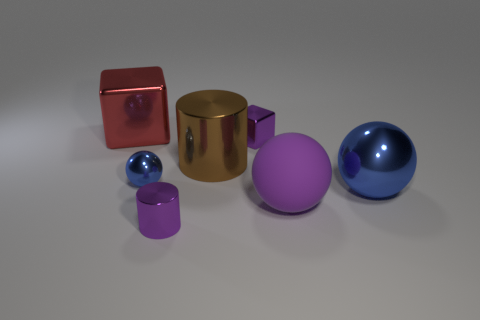What size is the matte object that is the same color as the tiny cylinder?
Keep it short and to the point. Large. How many things are to the left of the tiny cylinder and behind the brown shiny cylinder?
Your answer should be very brief. 1. How many things are big spheres or large objects that are to the left of the matte thing?
Your response must be concise. 4. The purple cube that is the same material as the large red cube is what size?
Your response must be concise. Small. What shape is the blue thing behind the ball that is right of the rubber object?
Give a very brief answer. Sphere. What number of brown objects are metallic cubes or large objects?
Provide a short and direct response. 1. Are there any tiny purple metallic cylinders that are on the left side of the big object that is to the left of the blue thing on the left side of the large purple rubber object?
Make the answer very short. No. There is a small metal object that is the same color as the tiny shiny block; what shape is it?
Give a very brief answer. Cylinder. Is there any other thing that has the same material as the red cube?
Provide a short and direct response. Yes. How many tiny things are either metal cylinders or purple objects?
Give a very brief answer. 2. 